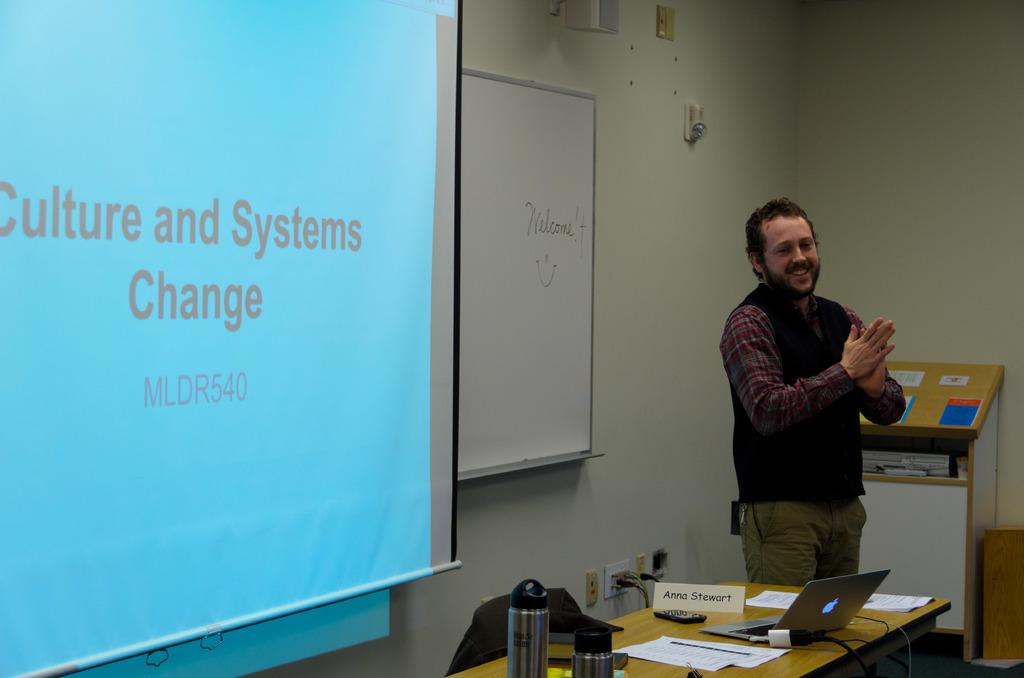<image>
Render a clear and concise summary of the photo. Teacher giving a lecture with title of "Culture and Systems Change" being projected behind him. 